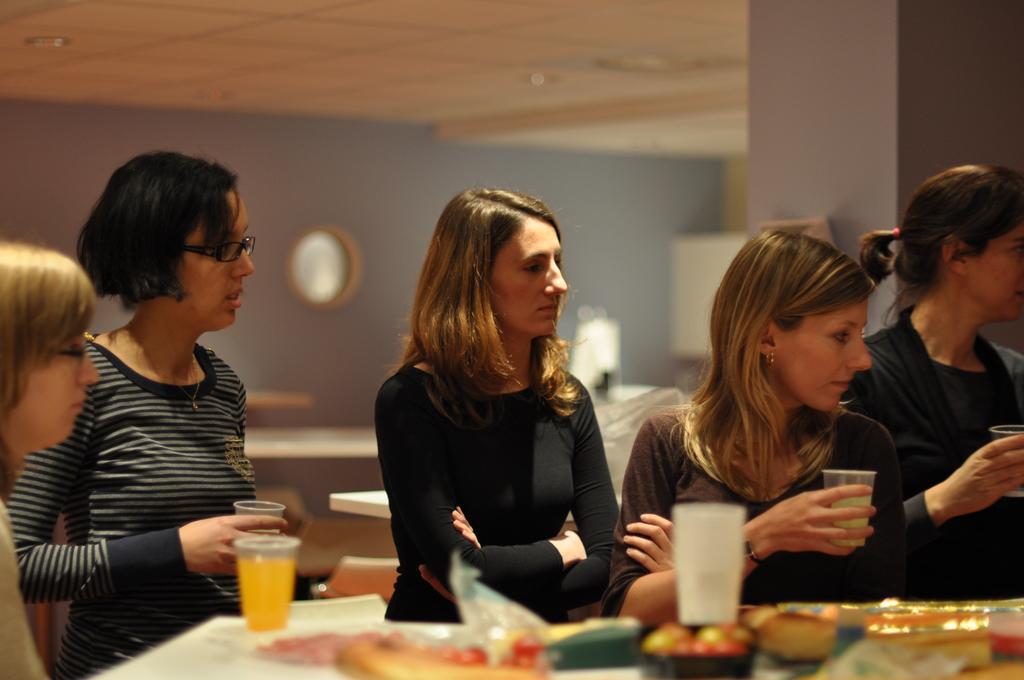Can you describe this image briefly? In this given picture, there are five women sitting in front of a table on which some glasses and food items were placed. In the background there is a wall here. 